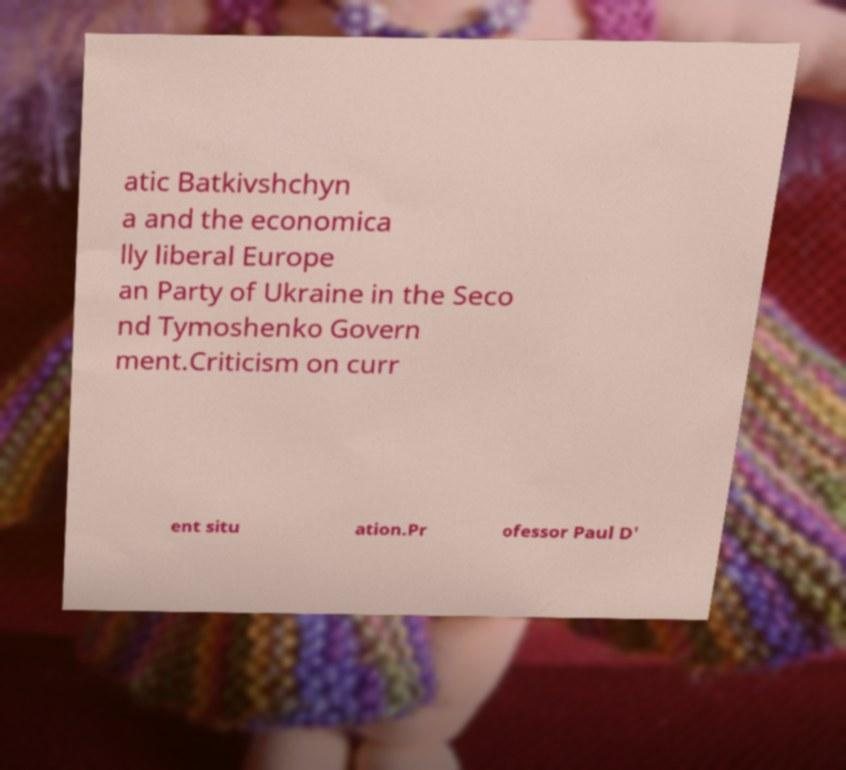Please read and relay the text visible in this image. What does it say? atic Batkivshchyn a and the economica lly liberal Europe an Party of Ukraine in the Seco nd Tymoshenko Govern ment.Criticism on curr ent situ ation.Pr ofessor Paul D' 